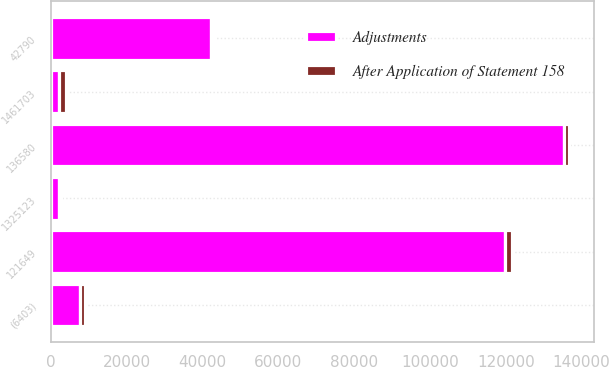Convert chart to OTSL. <chart><loc_0><loc_0><loc_500><loc_500><stacked_bar_chart><ecel><fcel>121649<fcel>1461703<fcel>42790<fcel>1325123<fcel>(6403)<fcel>136580<nl><fcel>After Application of Statement 158<fcel>1966<fcel>1966<fcel>658<fcel>658<fcel>1308<fcel>1308<nl><fcel>Adjustments<fcel>119683<fcel>1966<fcel>42132<fcel>1966<fcel>7711<fcel>135272<nl></chart> 